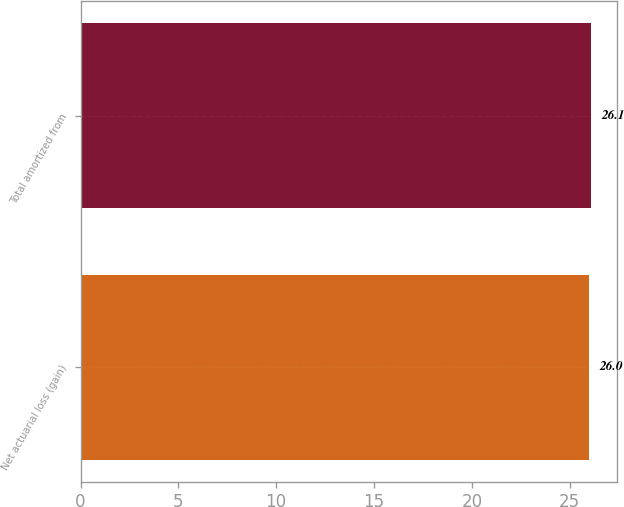Convert chart. <chart><loc_0><loc_0><loc_500><loc_500><bar_chart><fcel>Net actuarial loss (gain)<fcel>Total amortized from<nl><fcel>26<fcel>26.1<nl></chart> 